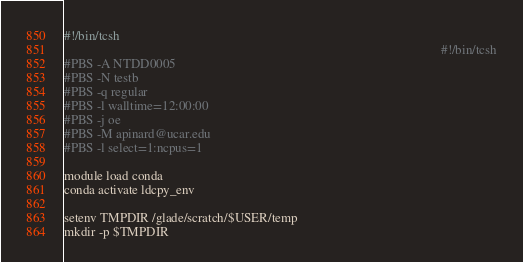Convert code to text. <code><loc_0><loc_0><loc_500><loc_500><_Bash_>#!/bin/tcsh
                                                                                                                    #!/bin/tcsh
#PBS -A NTDD0005
#PBS -N testb
#PBS -q regular
#PBS -l walltime=12:00:00
#PBS -j oe
#PBS -M apinard@ucar.edu
#PBS -l select=1:ncpus=1

module load conda
conda activate ldcpy_env

setenv TMPDIR /glade/scratch/$USER/temp
mkdir -p $TMPDIR
</code> 